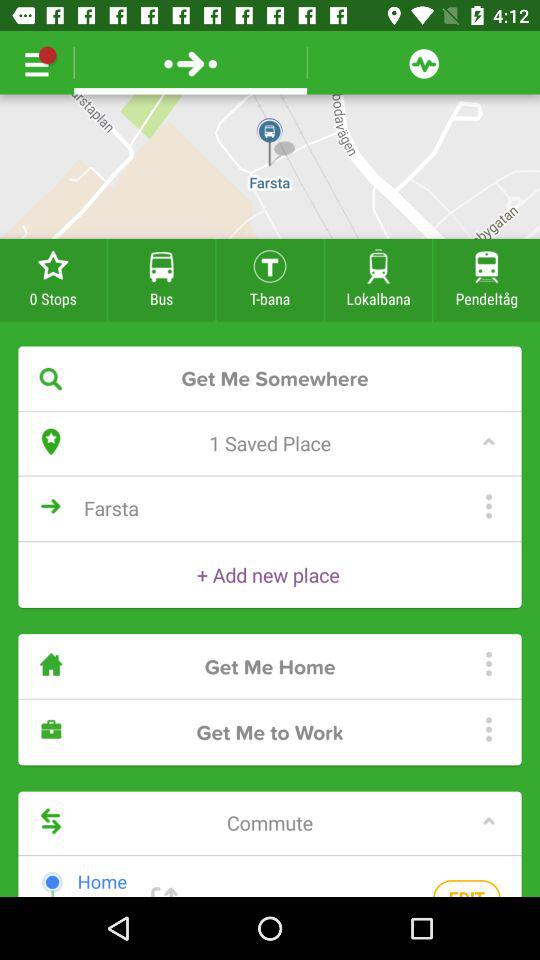How many options are available for transportation?
Answer the question using a single word or phrase. 5 